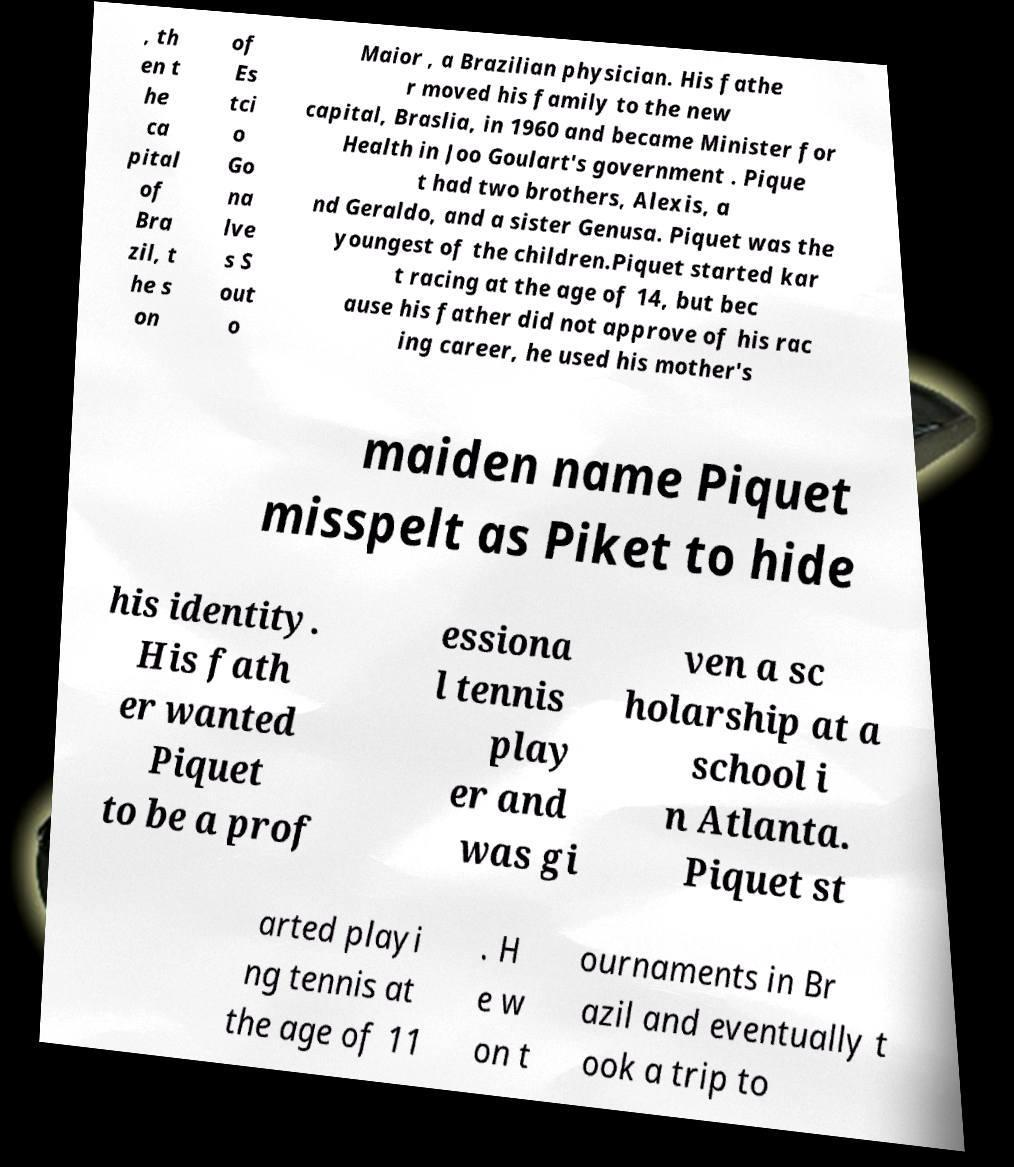Can you accurately transcribe the text from the provided image for me? , th en t he ca pital of Bra zil, t he s on of Es tci o Go na lve s S out o Maior , a Brazilian physician. His fathe r moved his family to the new capital, Braslia, in 1960 and became Minister for Health in Joo Goulart's government . Pique t had two brothers, Alexis, a nd Geraldo, and a sister Genusa. Piquet was the youngest of the children.Piquet started kar t racing at the age of 14, but bec ause his father did not approve of his rac ing career, he used his mother's maiden name Piquet misspelt as Piket to hide his identity. His fath er wanted Piquet to be a prof essiona l tennis play er and was gi ven a sc holarship at a school i n Atlanta. Piquet st arted playi ng tennis at the age of 11 . H e w on t ournaments in Br azil and eventually t ook a trip to 